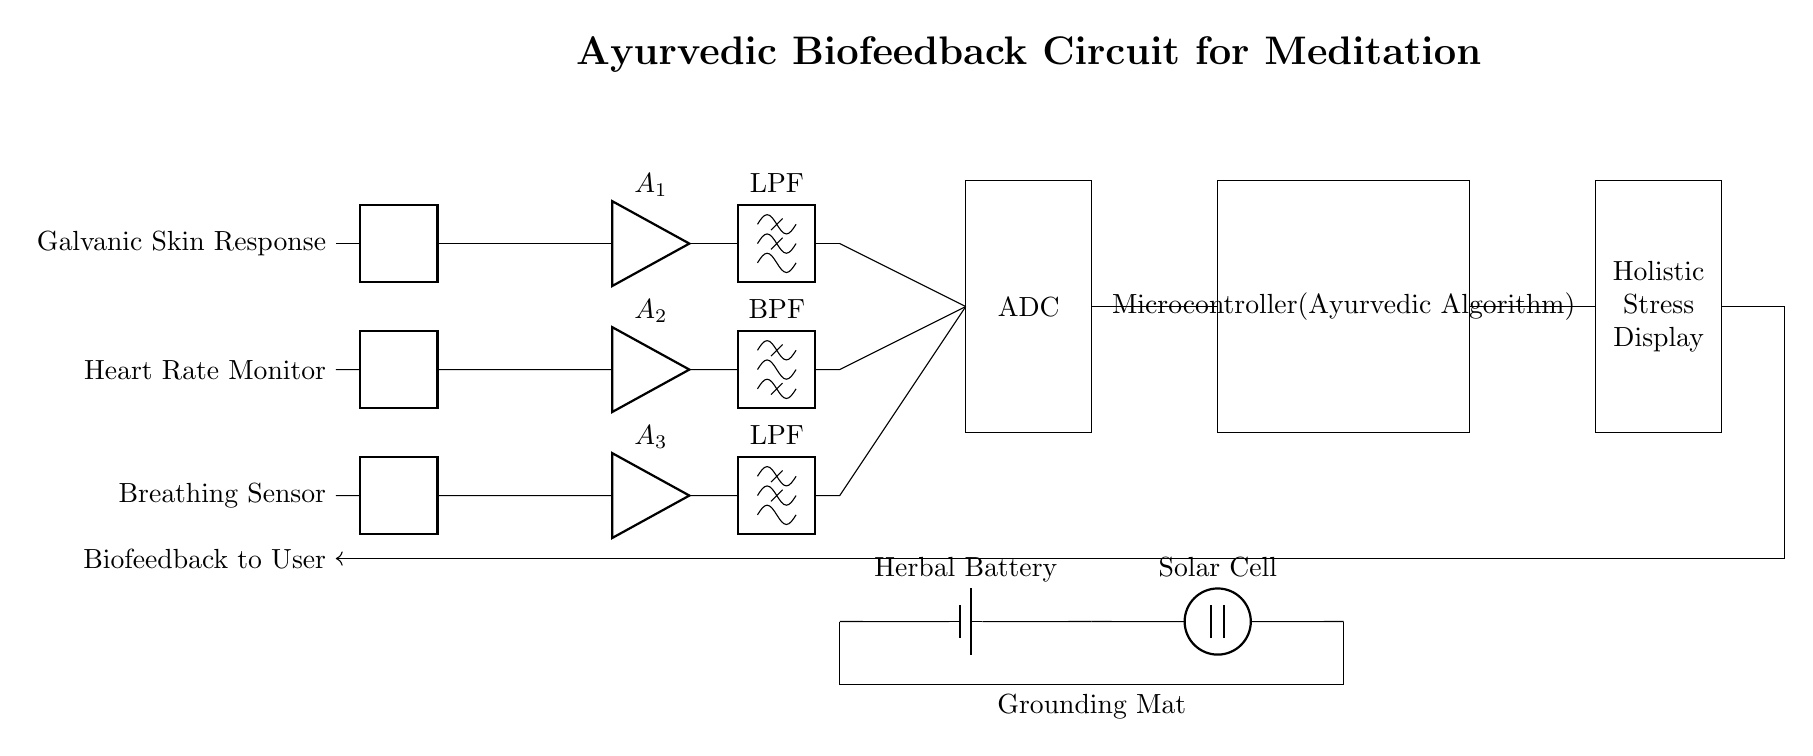What is the main purpose of this circuit? The circuit is designed to provide biofeedback for monitoring stress levels during meditation sessions by analyzing physiological signals.
Answer: Biofeedback for stress monitoring What type of sensors are included in the circuit? The circuit incorporates three types of sensors: a galvanic skin response sensor, a heart rate monitor, and a breathing sensor, which are used to collect physiological data.
Answer: Galvanic skin response, heart rate monitor, breathing sensor How many amplifiers are present in this circuit? There are three amplifiers in the circuit, each associated with one of the sensors to amplify the signals for further processing.
Answer: Three What type of display does the circuit use to show results? The circuit includes a holistic stress display designed to present the processed feedback information visually to the user.
Answer: Holistic Stress Display Explain how the microcontroller in this circuit contributes to its functionality. The microcontroller processes the signals received from the sensors via the ADC and utilizes an Ayurvedic algorithm to determine stress levels and provide feedback to the user, making it essential for the overall function of the circuit.
Answer: Processes signals and provides feedback What is the power source for this circuit? The circuit is powered by a herbal battery connected to a solar cell, promoting sustainability and aligning with holistic practices.
Answer: Herbal battery and solar cell What kind of signals are filtered in this circuit? The circuit employs a low-pass filter and a bandpass filter to filter the signals from the sensors, allowing for cleaner signal processing before analog to digital conversion.
Answer: Low-pass and bandpass filtered signals 